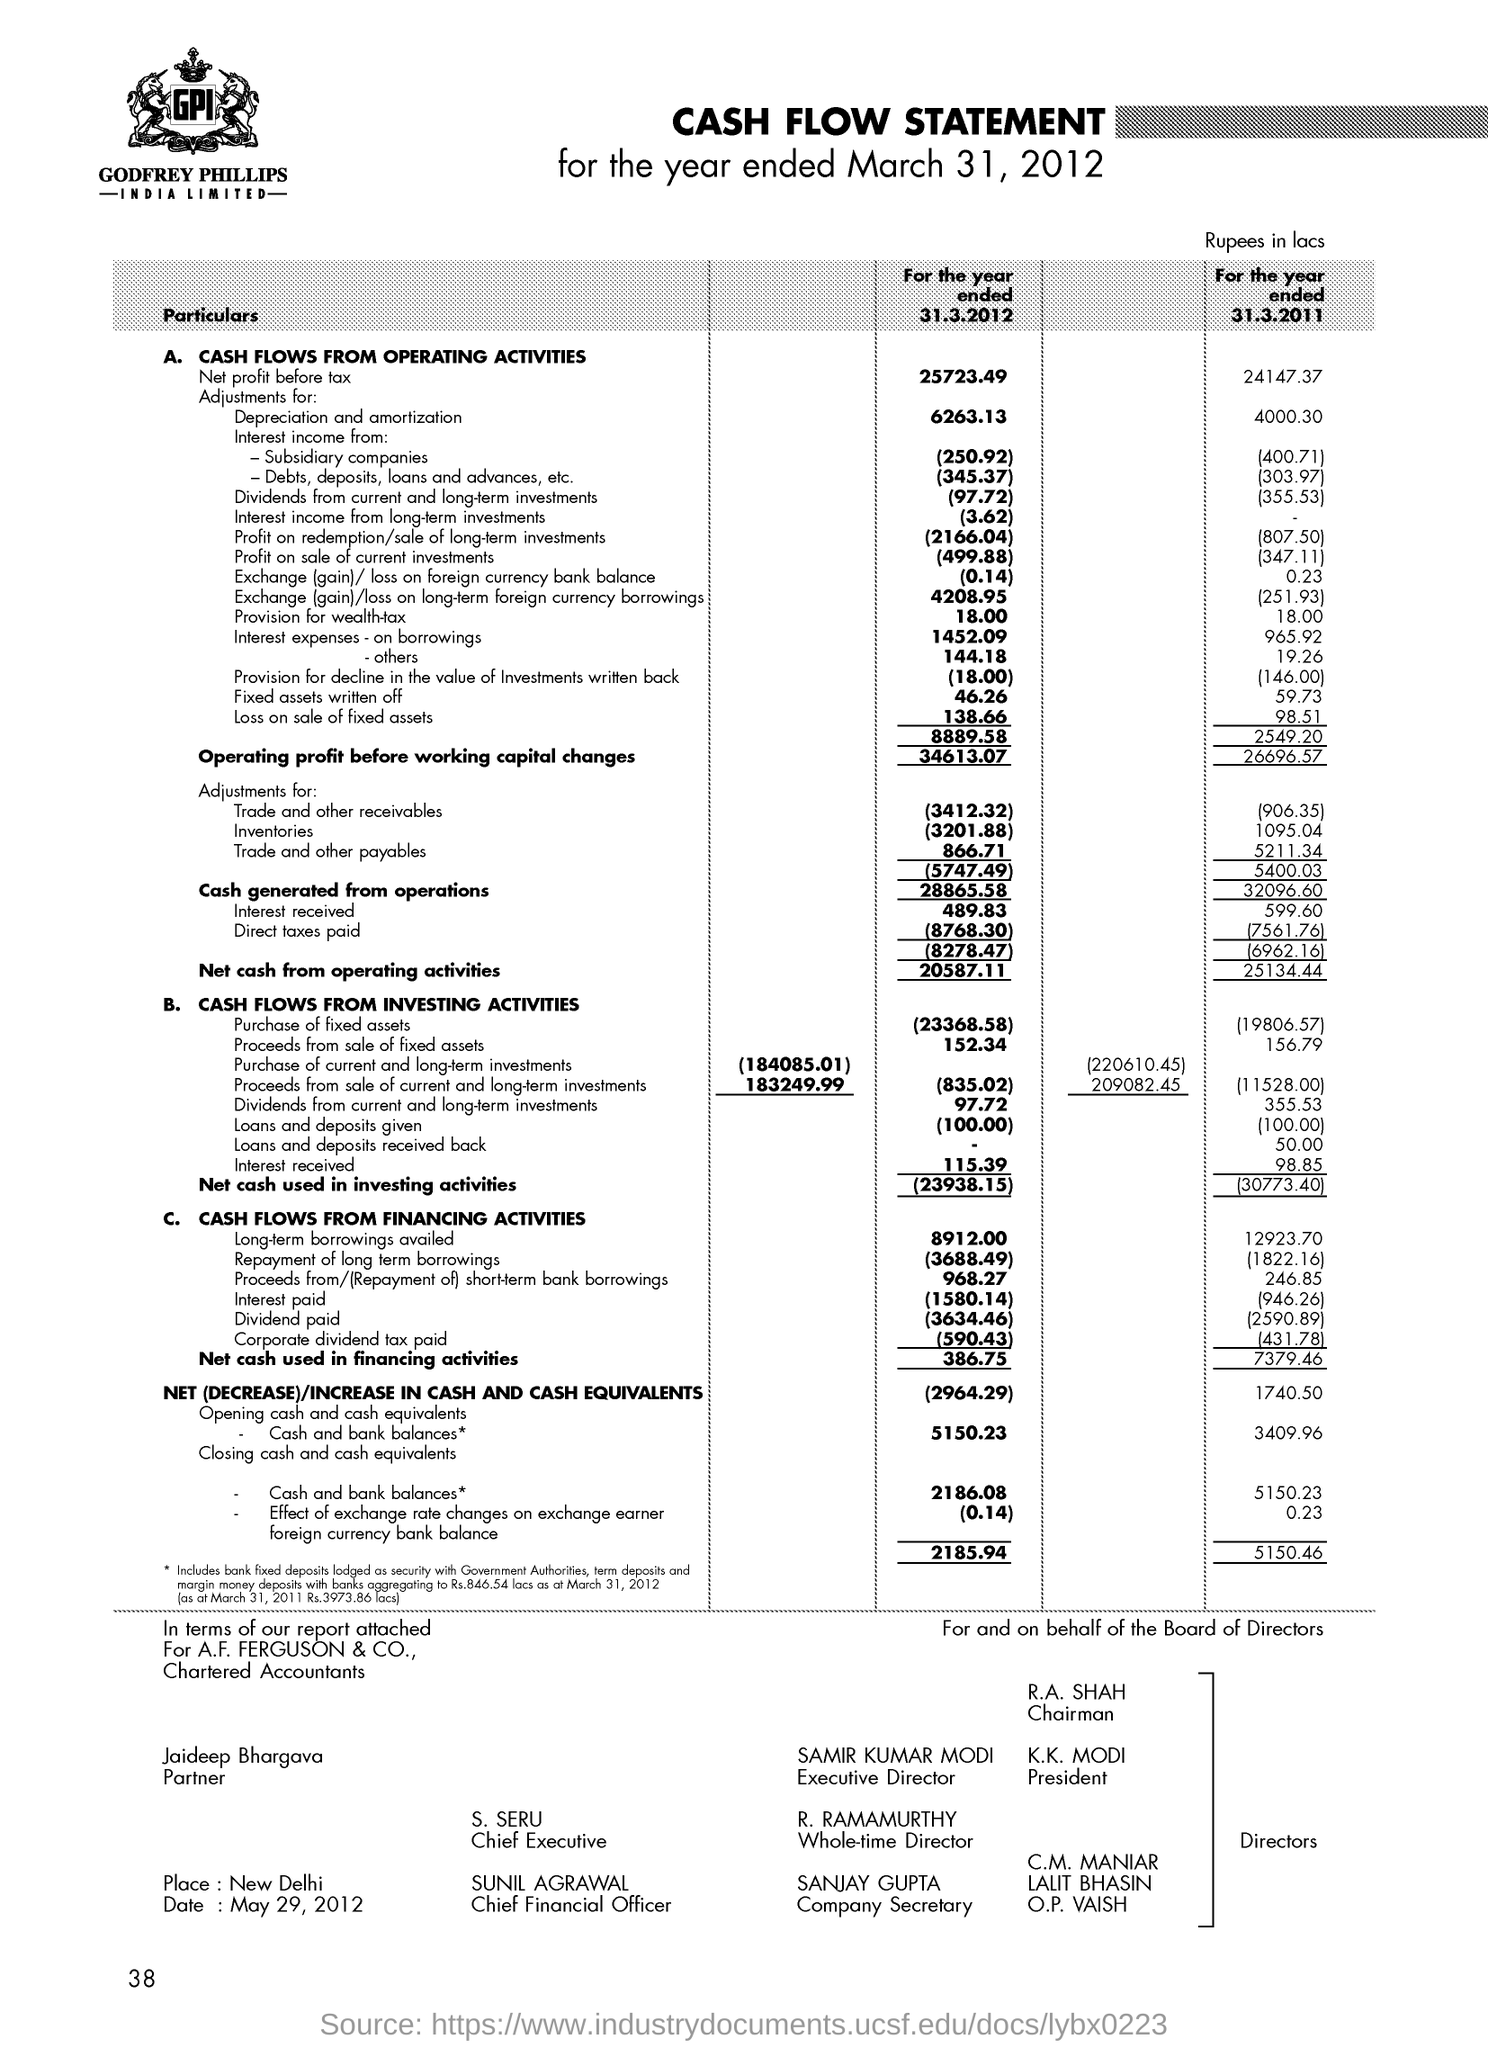What is the value of trade and other payables for the year ended 31.3.2012?
Keep it short and to the point. 866.71. Who is the Chief Financial Officer?
Provide a short and direct response. SUNIL AGRAWAL. 